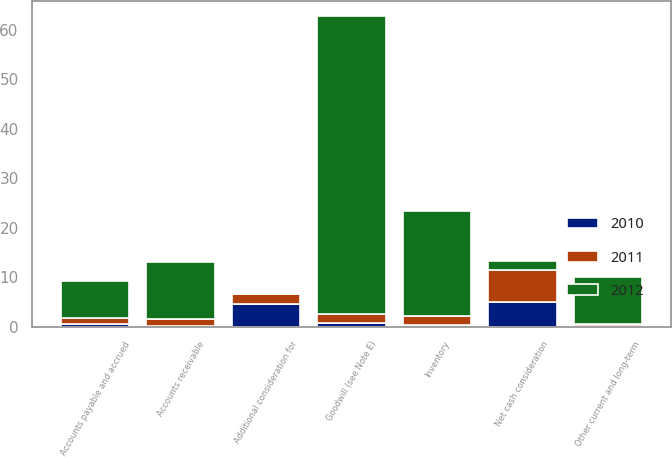<chart> <loc_0><loc_0><loc_500><loc_500><stacked_bar_chart><ecel><fcel>Accounts receivable<fcel>Inventory<fcel>Goodwill (see Note E)<fcel>Accounts payable and accrued<fcel>Other current and long-term<fcel>Additional consideration for<fcel>Net cash consideration<nl><fcel>2012<fcel>11.5<fcel>21.1<fcel>60.2<fcel>7.6<fcel>9.5<fcel>0.2<fcel>1.85<nl><fcel>2011<fcel>1.5<fcel>1.8<fcel>1.9<fcel>1.2<fcel>0.4<fcel>1.9<fcel>6.6<nl><fcel>2010<fcel>0.1<fcel>0.4<fcel>0.7<fcel>0.5<fcel>0.1<fcel>4.6<fcel>4.9<nl></chart> 